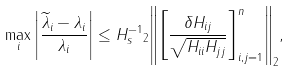Convert formula to latex. <formula><loc_0><loc_0><loc_500><loc_500>\max _ { i } \left | \frac { \widetilde { \lambda } _ { i } - \lambda _ { i } } { \lambda _ { i } } \right | \leq { \| H _ { s } ^ { - 1 } \| _ { 2 } } { \left \| \left [ \frac { \delta H _ { i j } } { \sqrt { H _ { i i } H _ { j j } } } \right ] _ { i , j = 1 } ^ { n } \right \| _ { 2 } } ,</formula> 